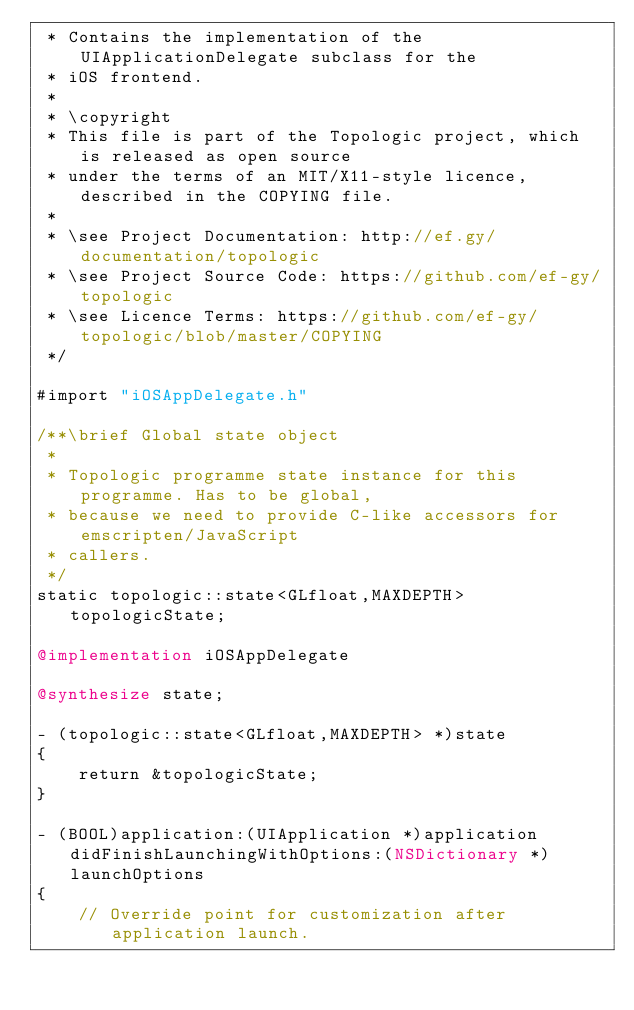Convert code to text. <code><loc_0><loc_0><loc_500><loc_500><_ObjectiveC_> * Contains the implementation of the UIApplicationDelegate subclass for the
 * iOS frontend.
 *
 * \copyright
 * This file is part of the Topologic project, which is released as open source
 * under the terms of an MIT/X11-style licence, described in the COPYING file.
 *
 * \see Project Documentation: http://ef.gy/documentation/topologic
 * \see Project Source Code: https://github.com/ef-gy/topologic
 * \see Licence Terms: https://github.com/ef-gy/topologic/blob/master/COPYING
 */

#import "iOSAppDelegate.h"

/**\brief Global state object
 *
 * Topologic programme state instance for this programme. Has to be global,
 * because we need to provide C-like accessors for emscripten/JavaScript
 * callers.
 */
static topologic::state<GLfloat,MAXDEPTH> topologicState;

@implementation iOSAppDelegate

@synthesize state;

- (topologic::state<GLfloat,MAXDEPTH> *)state
{
    return &topologicState;
}

- (BOOL)application:(UIApplication *)application didFinishLaunchingWithOptions:(NSDictionary *)launchOptions
{
    // Override point for customization after application launch.</code> 